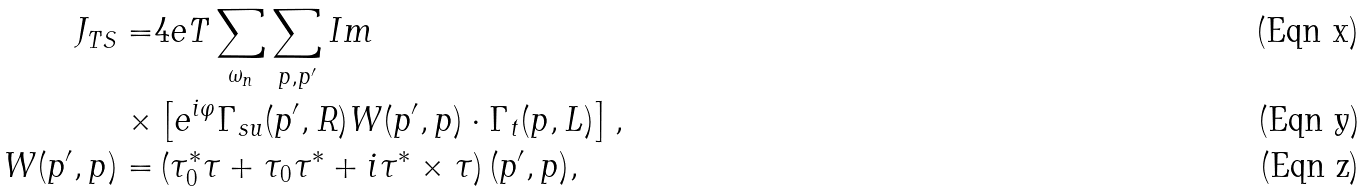Convert formula to latex. <formula><loc_0><loc_0><loc_500><loc_500>J _ { T S } = & 4 e T \sum _ { \omega _ { n } } \sum _ { p , p ^ { \prime } } I m \\ \times & \left [ e ^ { i \varphi } \Gamma _ { s u } ( p ^ { \prime } , R ) W ( p ^ { \prime } , p ) \cdot { \Gamma } _ { t } ( p , L ) \right ] , \\ W ( p ^ { \prime } , p ) = & \left ( \tau _ { 0 } ^ { \ast } { \tau } + \tau _ { 0 } { \tau } ^ { \ast } + i { \tau } ^ { \ast } \times { \tau } \right ) ( p ^ { \prime } , p ) ,</formula> 